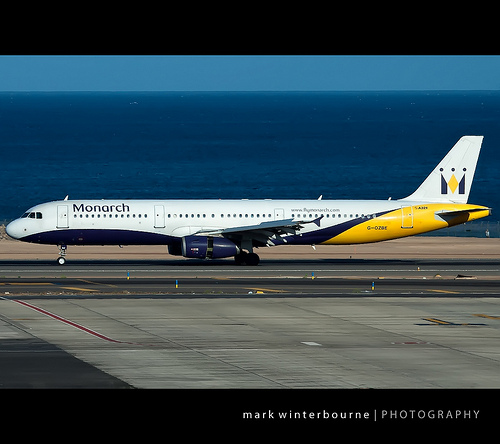Please provide a short description for this region: [0.89, 0.4, 0.92, 0.45]. A yellow diamond shape on the tail section of the plane. 